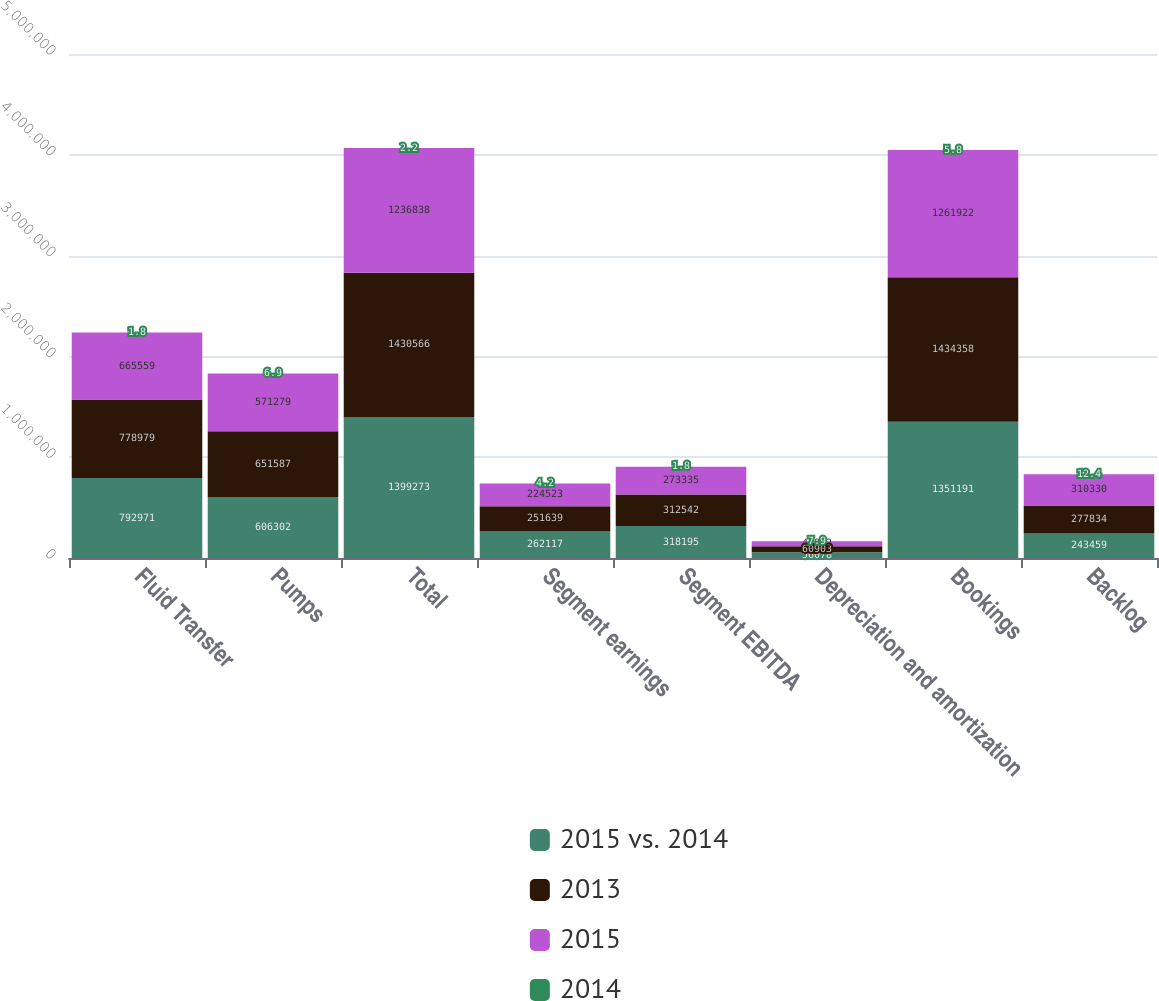Convert chart to OTSL. <chart><loc_0><loc_0><loc_500><loc_500><stacked_bar_chart><ecel><fcel>Fluid Transfer<fcel>Pumps<fcel>Total<fcel>Segment earnings<fcel>Segment EBITDA<fcel>Depreciation and amortization<fcel>Bookings<fcel>Backlog<nl><fcel>2015 vs. 2014<fcel>792971<fcel>606302<fcel>1.39927e+06<fcel>262117<fcel>318195<fcel>56078<fcel>1.35119e+06<fcel>243459<nl><fcel>2013<fcel>778979<fcel>651587<fcel>1.43057e+06<fcel>251639<fcel>312542<fcel>60903<fcel>1.43436e+06<fcel>277834<nl><fcel>2015<fcel>665559<fcel>571279<fcel>1.23684e+06<fcel>224523<fcel>273335<fcel>48812<fcel>1.26192e+06<fcel>310330<nl><fcel>2014<fcel>1.8<fcel>6.9<fcel>2.2<fcel>4.2<fcel>1.8<fcel>7.9<fcel>5.8<fcel>12.4<nl></chart> 